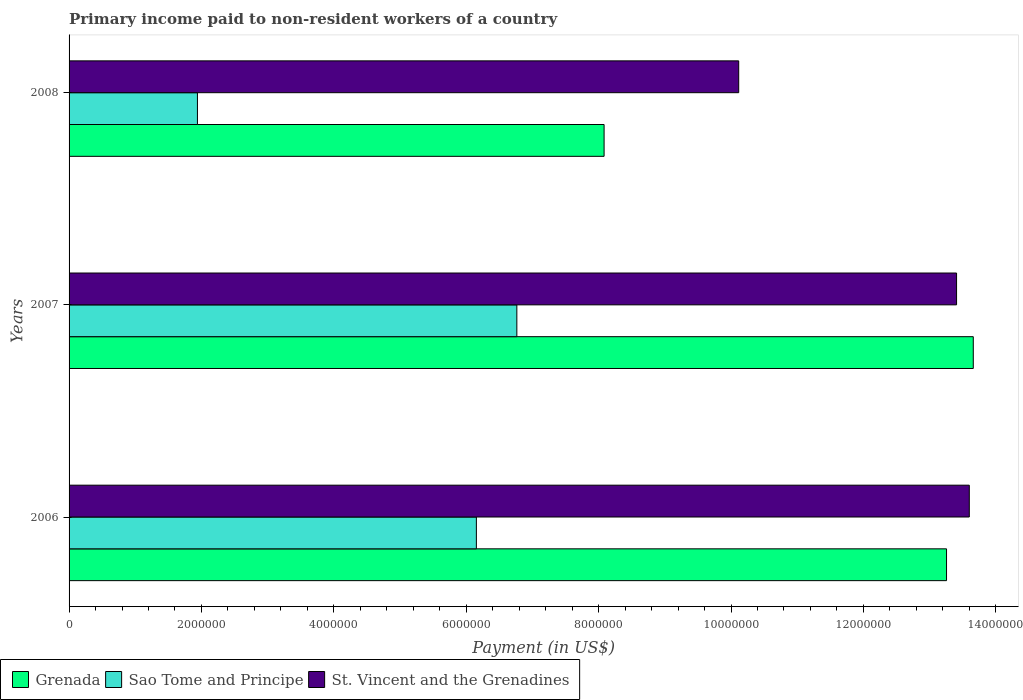How many different coloured bars are there?
Provide a short and direct response. 3. How many groups of bars are there?
Keep it short and to the point. 3. Are the number of bars per tick equal to the number of legend labels?
Your response must be concise. Yes. Are the number of bars on each tick of the Y-axis equal?
Keep it short and to the point. Yes. How many bars are there on the 1st tick from the top?
Your response must be concise. 3. What is the amount paid to workers in Sao Tome and Principe in 2008?
Provide a succinct answer. 1.94e+06. Across all years, what is the maximum amount paid to workers in St. Vincent and the Grenadines?
Provide a succinct answer. 1.36e+07. Across all years, what is the minimum amount paid to workers in Grenada?
Offer a very short reply. 8.08e+06. In which year was the amount paid to workers in St. Vincent and the Grenadines maximum?
Your answer should be compact. 2006. In which year was the amount paid to workers in Grenada minimum?
Provide a short and direct response. 2008. What is the total amount paid to workers in Sao Tome and Principe in the graph?
Give a very brief answer. 1.49e+07. What is the difference between the amount paid to workers in St. Vincent and the Grenadines in 2007 and that in 2008?
Provide a short and direct response. 3.29e+06. What is the difference between the amount paid to workers in St. Vincent and the Grenadines in 2006 and the amount paid to workers in Grenada in 2008?
Offer a terse response. 5.52e+06. What is the average amount paid to workers in Sao Tome and Principe per year?
Ensure brevity in your answer.  4.95e+06. In the year 2008, what is the difference between the amount paid to workers in Sao Tome and Principe and amount paid to workers in St. Vincent and the Grenadines?
Provide a short and direct response. -8.18e+06. What is the ratio of the amount paid to workers in Grenada in 2007 to that in 2008?
Offer a very short reply. 1.69. Is the difference between the amount paid to workers in Sao Tome and Principe in 2006 and 2008 greater than the difference between the amount paid to workers in St. Vincent and the Grenadines in 2006 and 2008?
Your answer should be very brief. Yes. What is the difference between the highest and the second highest amount paid to workers in Sao Tome and Principe?
Your answer should be compact. 6.11e+05. What is the difference between the highest and the lowest amount paid to workers in Grenada?
Your answer should be compact. 5.58e+06. What does the 2nd bar from the top in 2008 represents?
Give a very brief answer. Sao Tome and Principe. What does the 2nd bar from the bottom in 2007 represents?
Offer a terse response. Sao Tome and Principe. Is it the case that in every year, the sum of the amount paid to workers in St. Vincent and the Grenadines and amount paid to workers in Grenada is greater than the amount paid to workers in Sao Tome and Principe?
Make the answer very short. Yes. How many years are there in the graph?
Make the answer very short. 3. What is the difference between two consecutive major ticks on the X-axis?
Give a very brief answer. 2.00e+06. Are the values on the major ticks of X-axis written in scientific E-notation?
Your answer should be compact. No. How are the legend labels stacked?
Provide a succinct answer. Horizontal. What is the title of the graph?
Offer a very short reply. Primary income paid to non-resident workers of a country. What is the label or title of the X-axis?
Keep it short and to the point. Payment (in US$). What is the label or title of the Y-axis?
Ensure brevity in your answer.  Years. What is the Payment (in US$) in Grenada in 2006?
Offer a very short reply. 1.33e+07. What is the Payment (in US$) of Sao Tome and Principe in 2006?
Make the answer very short. 6.15e+06. What is the Payment (in US$) of St. Vincent and the Grenadines in 2006?
Keep it short and to the point. 1.36e+07. What is the Payment (in US$) in Grenada in 2007?
Your answer should be compact. 1.37e+07. What is the Payment (in US$) of Sao Tome and Principe in 2007?
Your answer should be compact. 6.76e+06. What is the Payment (in US$) of St. Vincent and the Grenadines in 2007?
Give a very brief answer. 1.34e+07. What is the Payment (in US$) of Grenada in 2008?
Ensure brevity in your answer.  8.08e+06. What is the Payment (in US$) of Sao Tome and Principe in 2008?
Provide a short and direct response. 1.94e+06. What is the Payment (in US$) in St. Vincent and the Grenadines in 2008?
Make the answer very short. 1.01e+07. Across all years, what is the maximum Payment (in US$) of Grenada?
Provide a short and direct response. 1.37e+07. Across all years, what is the maximum Payment (in US$) of Sao Tome and Principe?
Keep it short and to the point. 6.76e+06. Across all years, what is the maximum Payment (in US$) of St. Vincent and the Grenadines?
Your answer should be compact. 1.36e+07. Across all years, what is the minimum Payment (in US$) in Grenada?
Your response must be concise. 8.08e+06. Across all years, what is the minimum Payment (in US$) of Sao Tome and Principe?
Offer a terse response. 1.94e+06. Across all years, what is the minimum Payment (in US$) of St. Vincent and the Grenadines?
Offer a very short reply. 1.01e+07. What is the total Payment (in US$) in Grenada in the graph?
Provide a succinct answer. 3.50e+07. What is the total Payment (in US$) in Sao Tome and Principe in the graph?
Give a very brief answer. 1.49e+07. What is the total Payment (in US$) of St. Vincent and the Grenadines in the graph?
Make the answer very short. 3.71e+07. What is the difference between the Payment (in US$) in Grenada in 2006 and that in 2007?
Offer a terse response. -4.04e+05. What is the difference between the Payment (in US$) in Sao Tome and Principe in 2006 and that in 2007?
Your answer should be compact. -6.11e+05. What is the difference between the Payment (in US$) in St. Vincent and the Grenadines in 2006 and that in 2007?
Make the answer very short. 1.92e+05. What is the difference between the Payment (in US$) in Grenada in 2006 and that in 2008?
Provide a short and direct response. 5.17e+06. What is the difference between the Payment (in US$) in Sao Tome and Principe in 2006 and that in 2008?
Provide a short and direct response. 4.21e+06. What is the difference between the Payment (in US$) in St. Vincent and the Grenadines in 2006 and that in 2008?
Offer a terse response. 3.48e+06. What is the difference between the Payment (in US$) in Grenada in 2007 and that in 2008?
Keep it short and to the point. 5.58e+06. What is the difference between the Payment (in US$) in Sao Tome and Principe in 2007 and that in 2008?
Ensure brevity in your answer.  4.83e+06. What is the difference between the Payment (in US$) in St. Vincent and the Grenadines in 2007 and that in 2008?
Keep it short and to the point. 3.29e+06. What is the difference between the Payment (in US$) in Grenada in 2006 and the Payment (in US$) in Sao Tome and Principe in 2007?
Provide a short and direct response. 6.49e+06. What is the difference between the Payment (in US$) in Grenada in 2006 and the Payment (in US$) in St. Vincent and the Grenadines in 2007?
Ensure brevity in your answer.  -1.52e+05. What is the difference between the Payment (in US$) of Sao Tome and Principe in 2006 and the Payment (in US$) of St. Vincent and the Grenadines in 2007?
Your response must be concise. -7.25e+06. What is the difference between the Payment (in US$) in Grenada in 2006 and the Payment (in US$) in Sao Tome and Principe in 2008?
Your response must be concise. 1.13e+07. What is the difference between the Payment (in US$) in Grenada in 2006 and the Payment (in US$) in St. Vincent and the Grenadines in 2008?
Make the answer very short. 3.14e+06. What is the difference between the Payment (in US$) of Sao Tome and Principe in 2006 and the Payment (in US$) of St. Vincent and the Grenadines in 2008?
Offer a very short reply. -3.96e+06. What is the difference between the Payment (in US$) in Grenada in 2007 and the Payment (in US$) in Sao Tome and Principe in 2008?
Give a very brief answer. 1.17e+07. What is the difference between the Payment (in US$) in Grenada in 2007 and the Payment (in US$) in St. Vincent and the Grenadines in 2008?
Offer a terse response. 3.54e+06. What is the difference between the Payment (in US$) of Sao Tome and Principe in 2007 and the Payment (in US$) of St. Vincent and the Grenadines in 2008?
Keep it short and to the point. -3.35e+06. What is the average Payment (in US$) of Grenada per year?
Your response must be concise. 1.17e+07. What is the average Payment (in US$) of Sao Tome and Principe per year?
Provide a short and direct response. 4.95e+06. What is the average Payment (in US$) of St. Vincent and the Grenadines per year?
Your answer should be very brief. 1.24e+07. In the year 2006, what is the difference between the Payment (in US$) of Grenada and Payment (in US$) of Sao Tome and Principe?
Provide a short and direct response. 7.10e+06. In the year 2006, what is the difference between the Payment (in US$) in Grenada and Payment (in US$) in St. Vincent and the Grenadines?
Make the answer very short. -3.44e+05. In the year 2006, what is the difference between the Payment (in US$) of Sao Tome and Principe and Payment (in US$) of St. Vincent and the Grenadines?
Provide a succinct answer. -7.45e+06. In the year 2007, what is the difference between the Payment (in US$) of Grenada and Payment (in US$) of Sao Tome and Principe?
Your answer should be very brief. 6.90e+06. In the year 2007, what is the difference between the Payment (in US$) of Grenada and Payment (in US$) of St. Vincent and the Grenadines?
Ensure brevity in your answer.  2.52e+05. In the year 2007, what is the difference between the Payment (in US$) in Sao Tome and Principe and Payment (in US$) in St. Vincent and the Grenadines?
Offer a very short reply. -6.64e+06. In the year 2008, what is the difference between the Payment (in US$) of Grenada and Payment (in US$) of Sao Tome and Principe?
Provide a short and direct response. 6.14e+06. In the year 2008, what is the difference between the Payment (in US$) in Grenada and Payment (in US$) in St. Vincent and the Grenadines?
Ensure brevity in your answer.  -2.03e+06. In the year 2008, what is the difference between the Payment (in US$) in Sao Tome and Principe and Payment (in US$) in St. Vincent and the Grenadines?
Ensure brevity in your answer.  -8.18e+06. What is the ratio of the Payment (in US$) in Grenada in 2006 to that in 2007?
Provide a succinct answer. 0.97. What is the ratio of the Payment (in US$) of Sao Tome and Principe in 2006 to that in 2007?
Make the answer very short. 0.91. What is the ratio of the Payment (in US$) in St. Vincent and the Grenadines in 2006 to that in 2007?
Give a very brief answer. 1.01. What is the ratio of the Payment (in US$) in Grenada in 2006 to that in 2008?
Offer a very short reply. 1.64. What is the ratio of the Payment (in US$) of Sao Tome and Principe in 2006 to that in 2008?
Make the answer very short. 3.17. What is the ratio of the Payment (in US$) in St. Vincent and the Grenadines in 2006 to that in 2008?
Offer a terse response. 1.34. What is the ratio of the Payment (in US$) in Grenada in 2007 to that in 2008?
Your answer should be very brief. 1.69. What is the ratio of the Payment (in US$) of Sao Tome and Principe in 2007 to that in 2008?
Keep it short and to the point. 3.49. What is the ratio of the Payment (in US$) in St. Vincent and the Grenadines in 2007 to that in 2008?
Your response must be concise. 1.33. What is the difference between the highest and the second highest Payment (in US$) of Grenada?
Provide a succinct answer. 4.04e+05. What is the difference between the highest and the second highest Payment (in US$) of Sao Tome and Principe?
Your answer should be compact. 6.11e+05. What is the difference between the highest and the second highest Payment (in US$) in St. Vincent and the Grenadines?
Ensure brevity in your answer.  1.92e+05. What is the difference between the highest and the lowest Payment (in US$) in Grenada?
Provide a short and direct response. 5.58e+06. What is the difference between the highest and the lowest Payment (in US$) of Sao Tome and Principe?
Keep it short and to the point. 4.83e+06. What is the difference between the highest and the lowest Payment (in US$) of St. Vincent and the Grenadines?
Make the answer very short. 3.48e+06. 